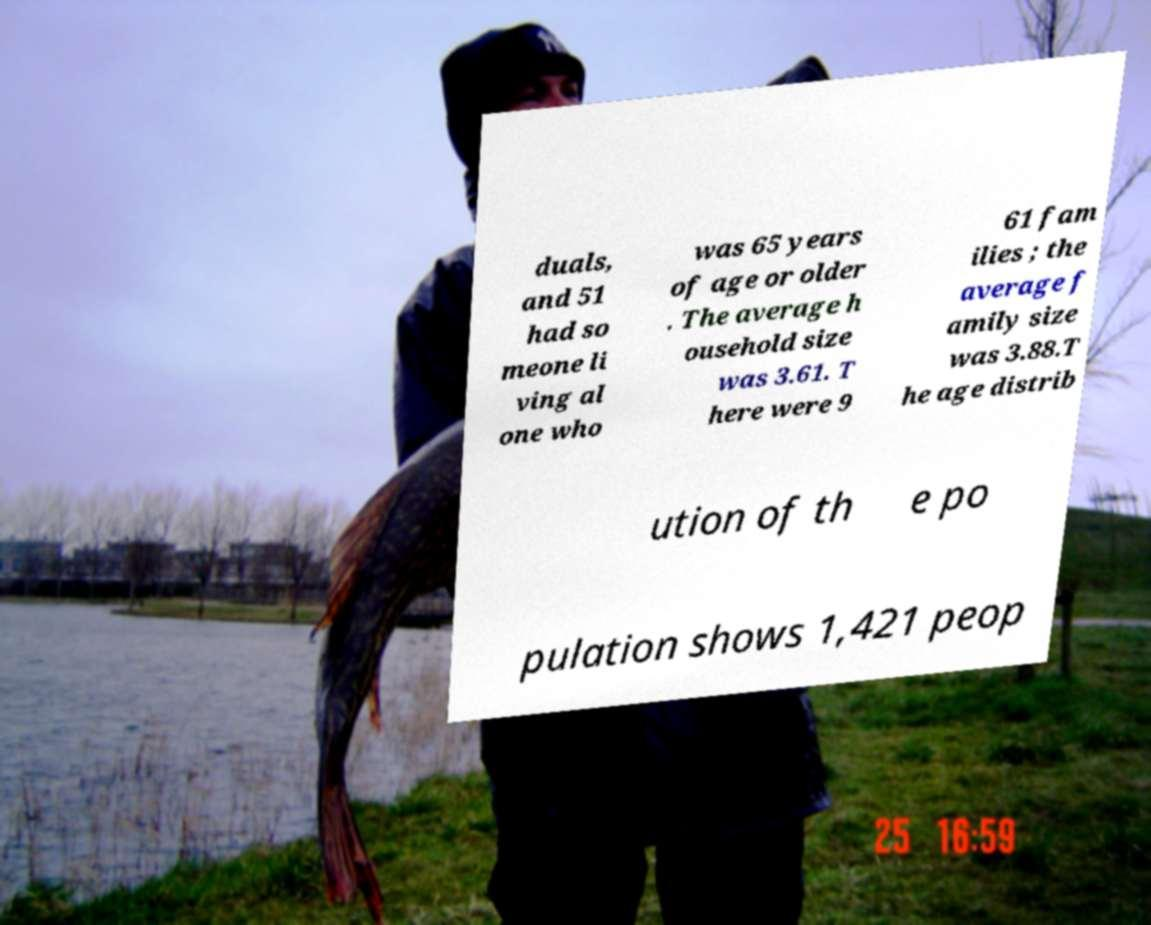Could you extract and type out the text from this image? duals, and 51 had so meone li ving al one who was 65 years of age or older . The average h ousehold size was 3.61. T here were 9 61 fam ilies ; the average f amily size was 3.88.T he age distrib ution of th e po pulation shows 1,421 peop 